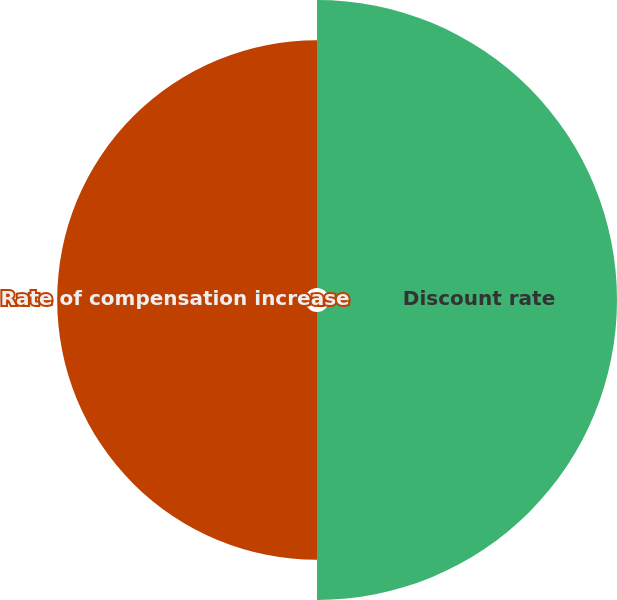Convert chart to OTSL. <chart><loc_0><loc_0><loc_500><loc_500><pie_chart><fcel>Discount rate<fcel>Rate of compensation increase<nl><fcel>53.75%<fcel>46.25%<nl></chart> 